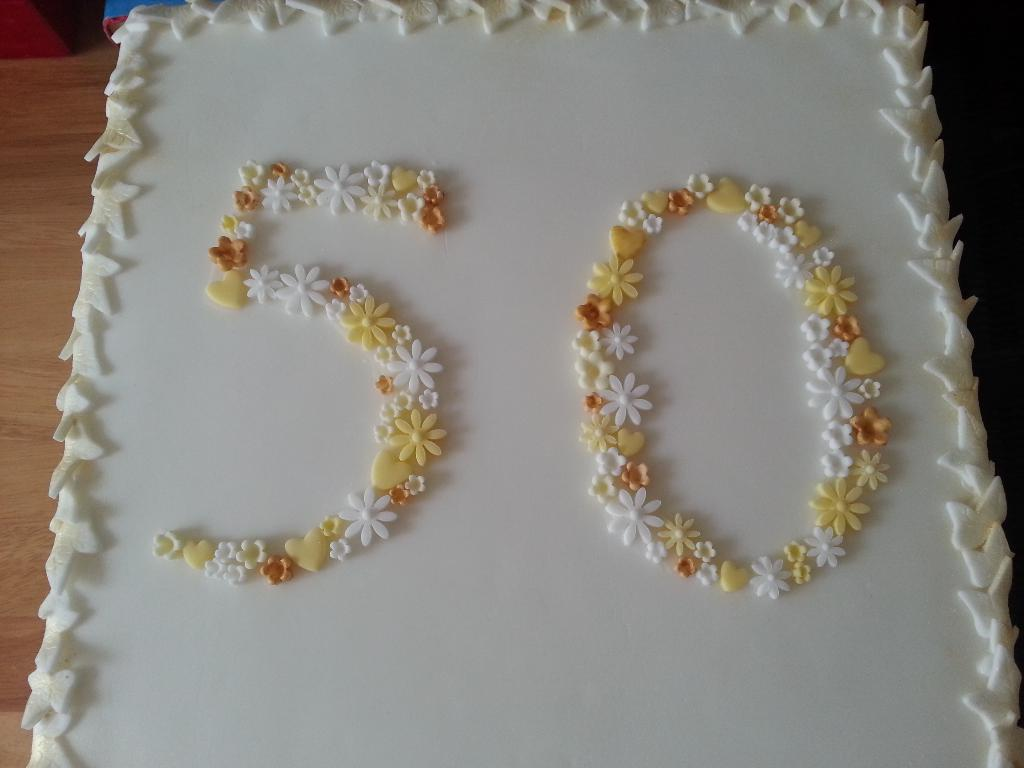What is on the table in the image? There is a cake on the table. What is on top of the cake? The cake has cream on it. How is the cream on the cake designed? The cream is carved in the structure of flowers and leaves. What type of animal is sitting next to the cake in the image? There is no animal present in the image; it only features a cake with cream carved in the structure of flowers and leaves. 